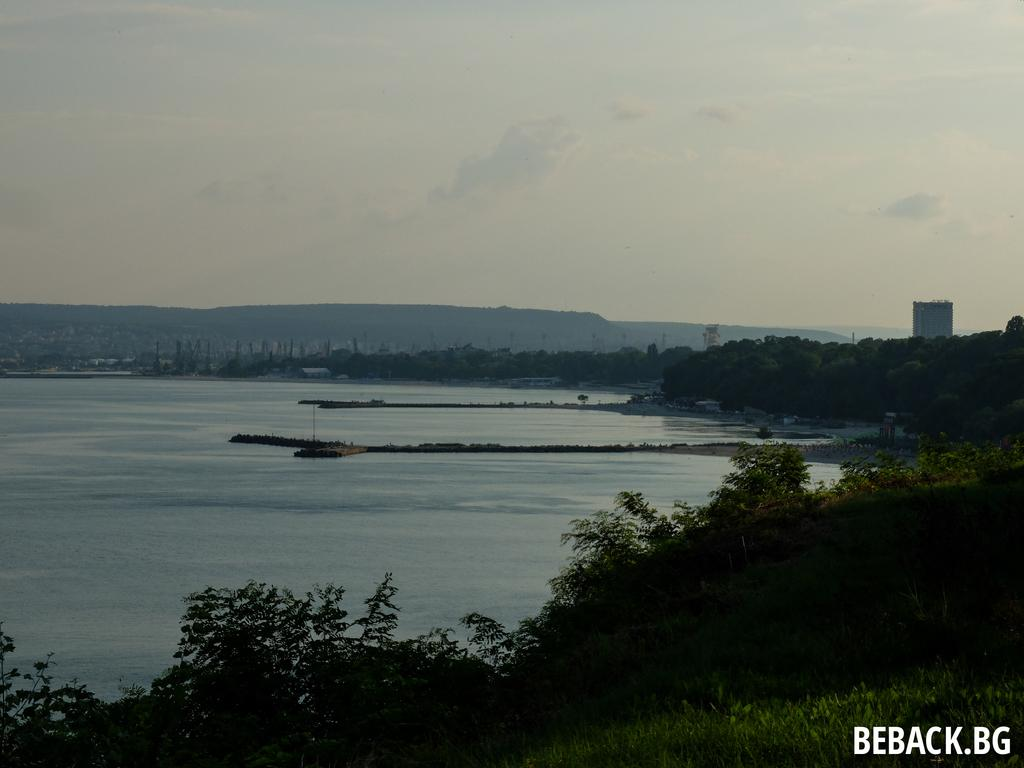What type of natural feature is located on the left side of the image? There is a sea on the left side of the image. What type of vegetation is on the right side of the image? Trees are present on the right side of the image. What can be seen in the background of the image? There appears to be a hill in the background of the image. What is visible in the sky in the image? The sky is visible in the image, and clouds are present in the sky. What type of jam is being used to paint the end of the hill in the image? There is no jam or painting activity present in the image; it features a sea, trees, a hill, and a sky with clouds. 